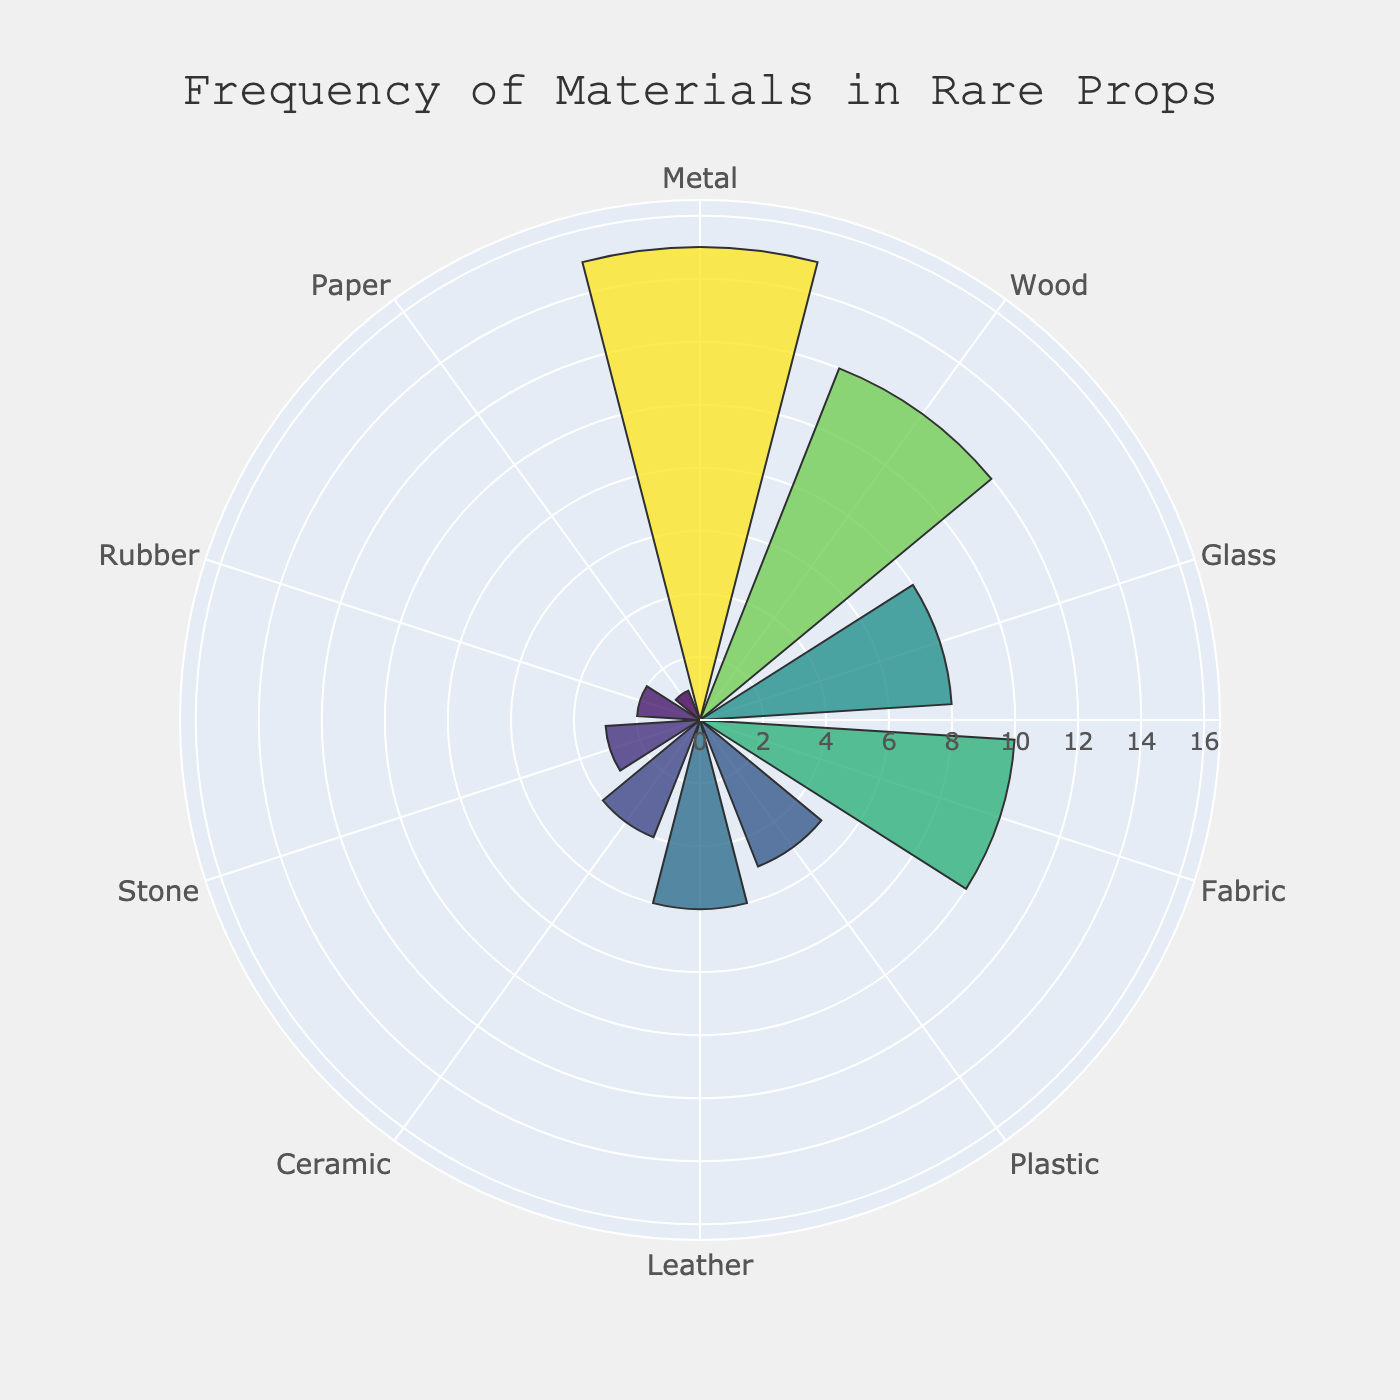What is the most frequently used material in rare props according to the chart? The chart shows radial bars for different materials, with the length representing frequency. The material with the longest bar is Metal.
Answer: Metal What is the title of the rose chart? The title is displayed prominently at the top of the chart. It reads "Frequency of Materials in Rare Props".
Answer: Frequency of Materials in Rare Props How many materials have a frequency of 10 or more? By examining the radial bars, we see that Metal (15), Wood (12), and Fabric (10) have frequencies of 10 or more. This counts to 3 materials.
Answer: 3 Which material has the least frequency and what is its value? The shortest bar in the chart corresponds to the material Paper with a frequency of 1, which is the lowest value shown.
Answer: Paper, 1 What is the combined frequency of Glass, Leather, and Plastic? The chart shows Glass (8), Leather (6), and Plastic (5). Adding these frequencies together gives 8 + 6 + 5 = 19.
Answer: 19 Which material has a higher frequency: Fabric or Plastic? The chart shows radial bars for both Fabric and Plastic. Fabric's bar extends to 10, while Plastic's bar extends to 5. Therefore, Fabric has a higher frequency.
Answer: Fabric What is the difference in frequency between Metal and Stone? According to the chart, Metal has a frequency of 15 and Stone has a frequency of 3. The difference is 15 - 3 = 12.
Answer: 12 How many materials have a frequency less than 5? The chart shows materials with frequencies below 5: Ceramic (4), Stone (3), Rubber (2), and Paper (1), which totals to 4 materials.
Answer: 4 Which materials have a frequency between 5 and 10 (exclusive)? Examining the chart, the materials in this range are Plastic (5) and Leather (6). Note: 5 and 10 are excluded from this count.
Answer: Leather 